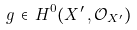<formula> <loc_0><loc_0><loc_500><loc_500>g \, \in \, H ^ { 0 } ( X ^ { \prime } \, , { \mathcal { O } } _ { X ^ { \prime } } )</formula> 